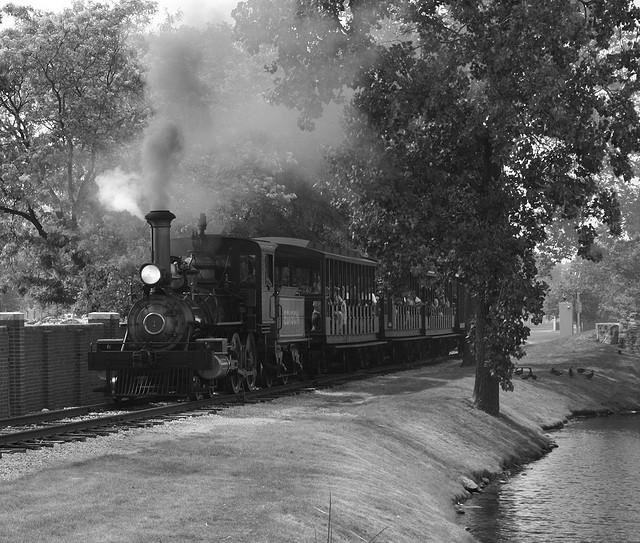What is the state of the colors here?

Choices:
A) inverted
B) normal
C) black/white
D) super saturated black/white 